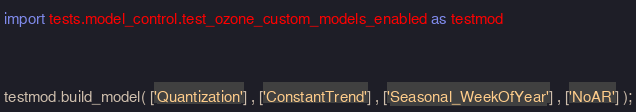<code> <loc_0><loc_0><loc_500><loc_500><_Python_>import tests.model_control.test_ozone_custom_models_enabled as testmod


testmod.build_model( ['Quantization'] , ['ConstantTrend'] , ['Seasonal_WeekOfYear'] , ['NoAR'] );</code> 